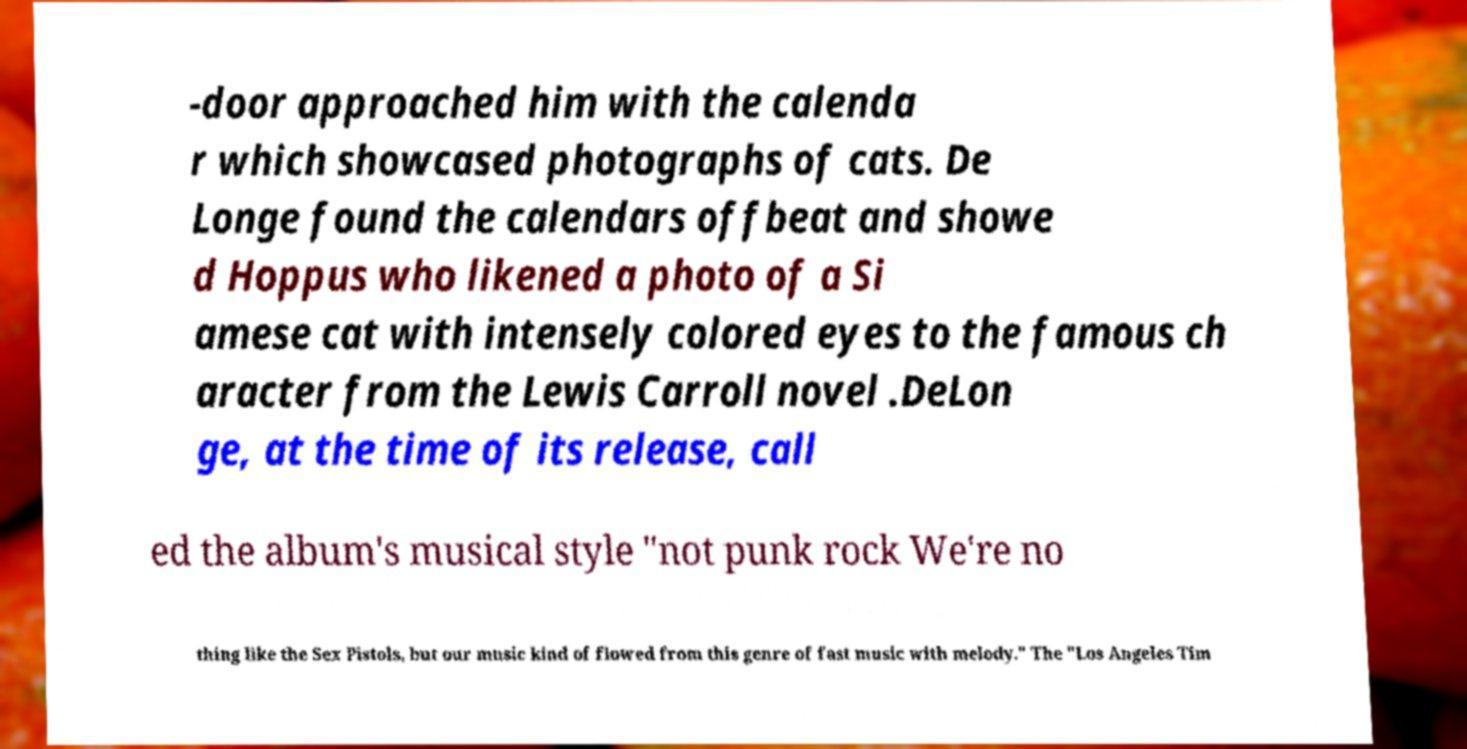I need the written content from this picture converted into text. Can you do that? -door approached him with the calenda r which showcased photographs of cats. De Longe found the calendars offbeat and showe d Hoppus who likened a photo of a Si amese cat with intensely colored eyes to the famous ch aracter from the Lewis Carroll novel .DeLon ge, at the time of its release, call ed the album's musical style "not punk rock We're no thing like the Sex Pistols, but our music kind of flowed from this genre of fast music with melody." The "Los Angeles Tim 